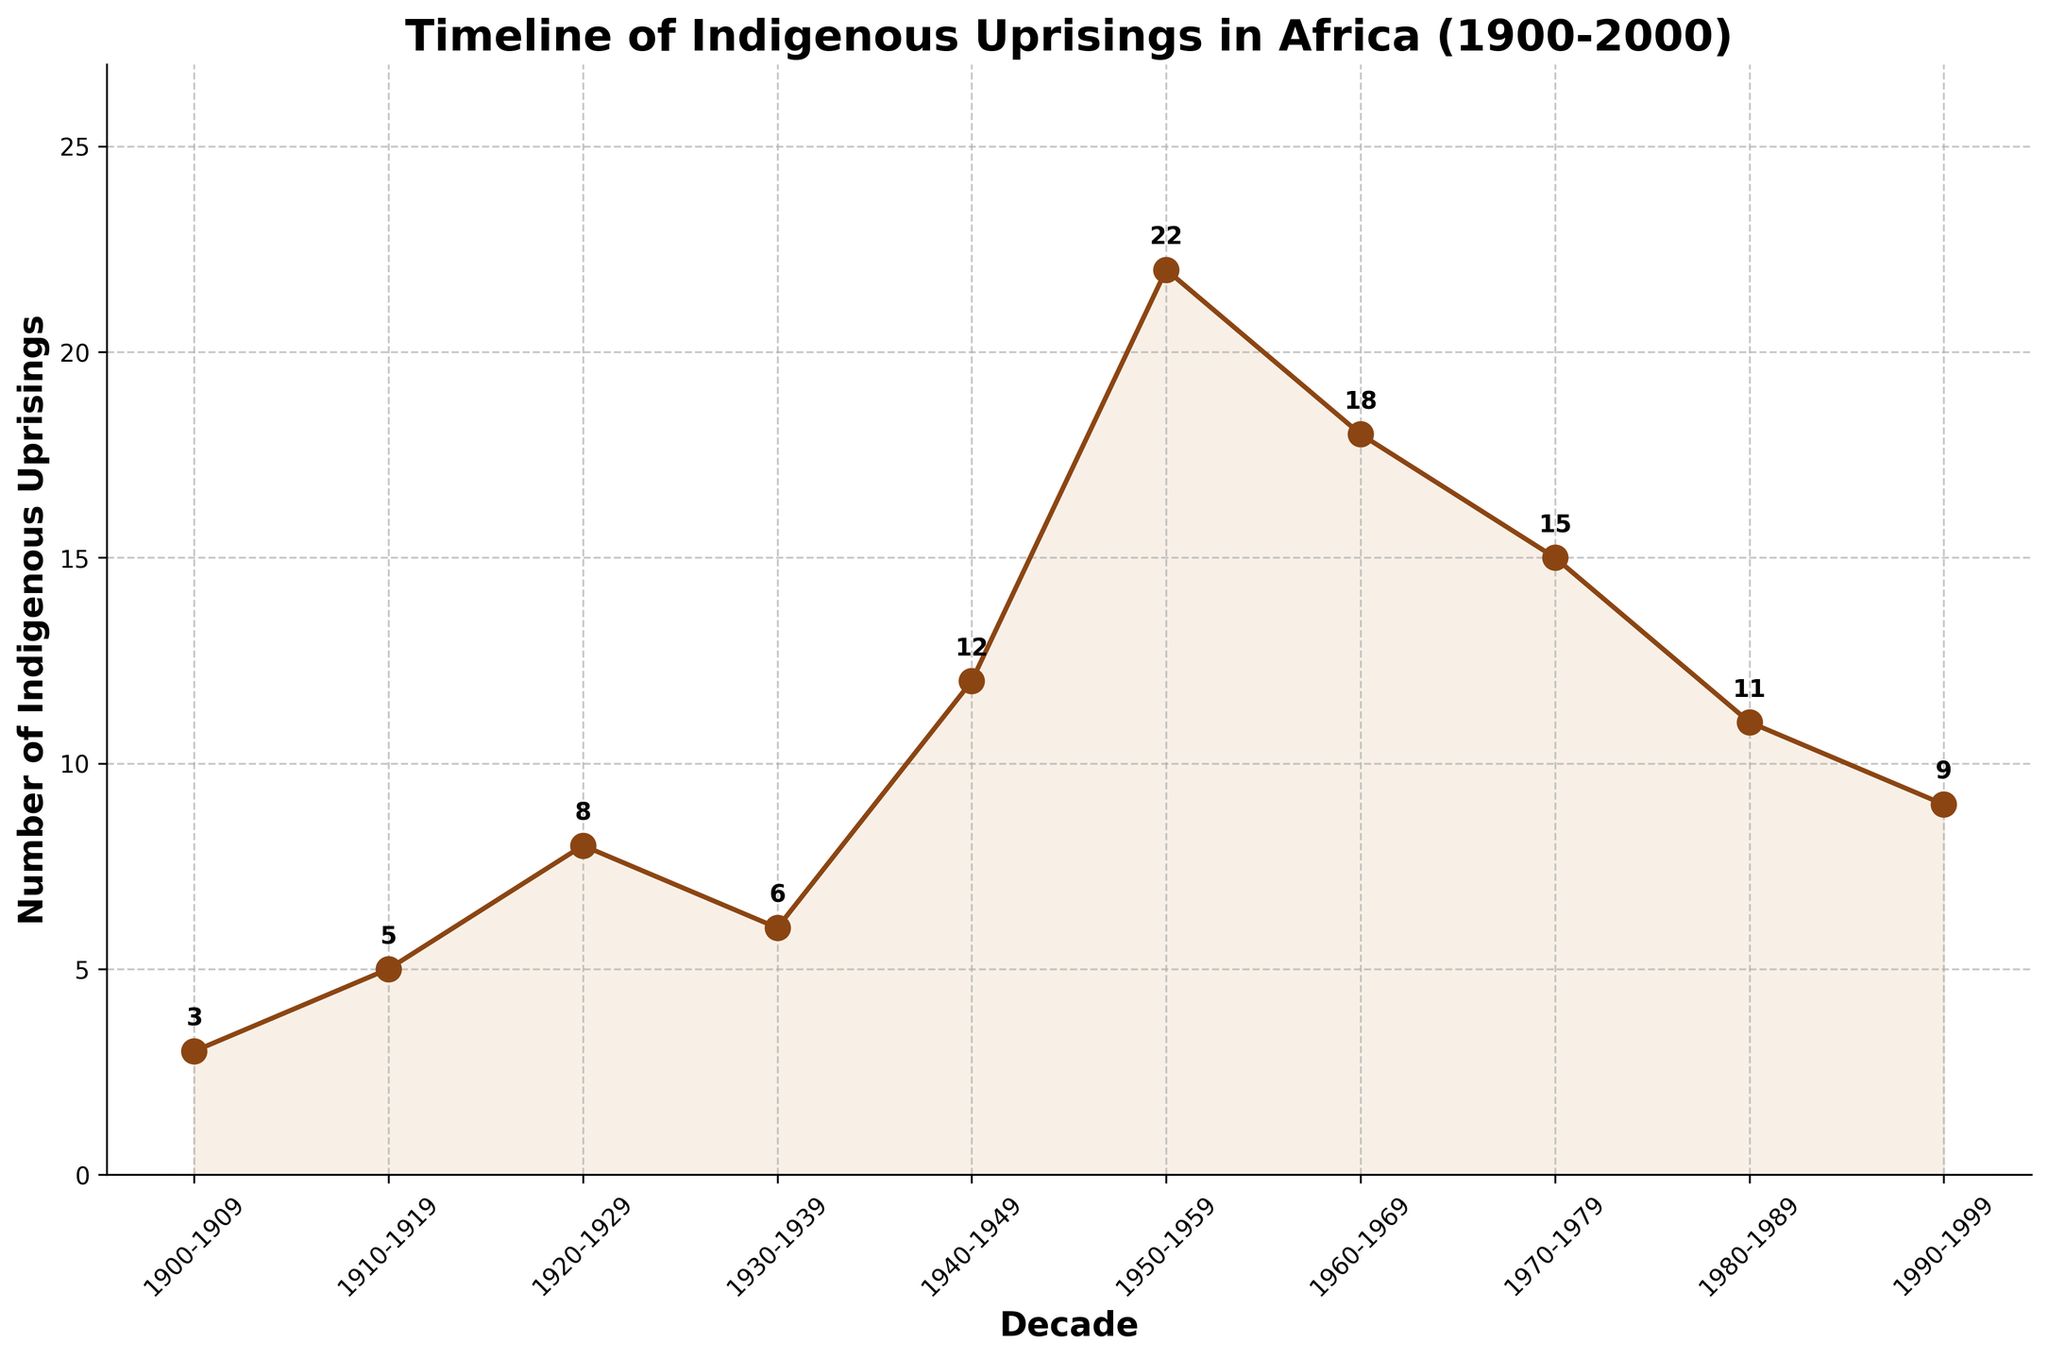How many indigenous uprisings were there in total between 1900 and 1959? To find the total, sum the number of uprisings for the decades 1900-1909, 1910-1919, 1920-1929, 1930-1939, 1940-1949, and 1950-1959. The numbers are 3, 5, 8, 6, 12, and 22 respectively. Therefore, 3 + 5 + 8 + 6 + 12 + 22 = 56
Answer: 56 Which decade had the highest number of indigenous uprisings, and what was that number? To find the highest number of uprisings, look at each decade's values and identify the maximum. The maximum here is 22 in the 1950-1959 decade.
Answer: 1950-1959, 22 Between which two consecutive decades was the drop in indigenous uprisings the largest? Compare the differences between the number of uprisings in consecutive decades. The largest drop is between 1960-1969 and 1970-1979, with a decrease from 18 to 15, a difference of 3.
Answer: 1960-1969 to 1970-1979 In terms of general trends, how does the frequency of indigenous uprisings change throughout the century? In general, the frequency increases from 1900 to the mid-20th century, peaks during the 1950-1959 decade, and then gradually decreases towards the end of the century.
Answer: Increases, peaks in mid-century, then decreases Which decade had exactly half the number of uprisings compared to the 1950-1959 decade, and how many uprisings were there? The 1950-1959 decade had 22 uprisings. Half of 22 is 11. The 1980-1989 decade had exactly 11 uprisings.
Answer: 1980-1989, 11 How many more uprisings were there in the 1940-1949 decade compared to the 1930-1939 decade? Subtract the number of uprisings in the 1930-1939 decade (6) from the 1940-1949 decade (12). The result is 12 - 6 = 6 more uprisings.
Answer: 6 How does the number of uprisings in the 1970-1979 decade compare to the decade immediately following it? In the 1970-1979 decade, there were 15 uprisings, whereas in the 1980-1989 decade, there were 11 uprisings. Thus, the 1970-1979 decade had 4 more uprisings.
Answer: 4 more uprisings What is the average number of indigenous uprisings per decade from 1900 to 2000? Sum all the indigenous uprisings first (3 + 5 + 8 + 6 + 12 + 22 + 18 + 15 + 11 + 9 = 109) and then divide by the number of decades (10). Therefore, 109 / 10 = 10.9 per decade on average.
Answer: 10.9 